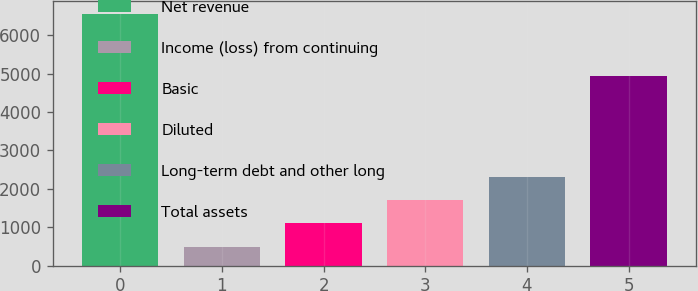Convert chart. <chart><loc_0><loc_0><loc_500><loc_500><bar_chart><fcel>Net revenue<fcel>Income (loss) from continuing<fcel>Basic<fcel>Diluted<fcel>Long-term debt and other long<fcel>Total assets<nl><fcel>6568<fcel>495<fcel>1102.3<fcel>1709.6<fcel>2316.9<fcel>4954<nl></chart> 